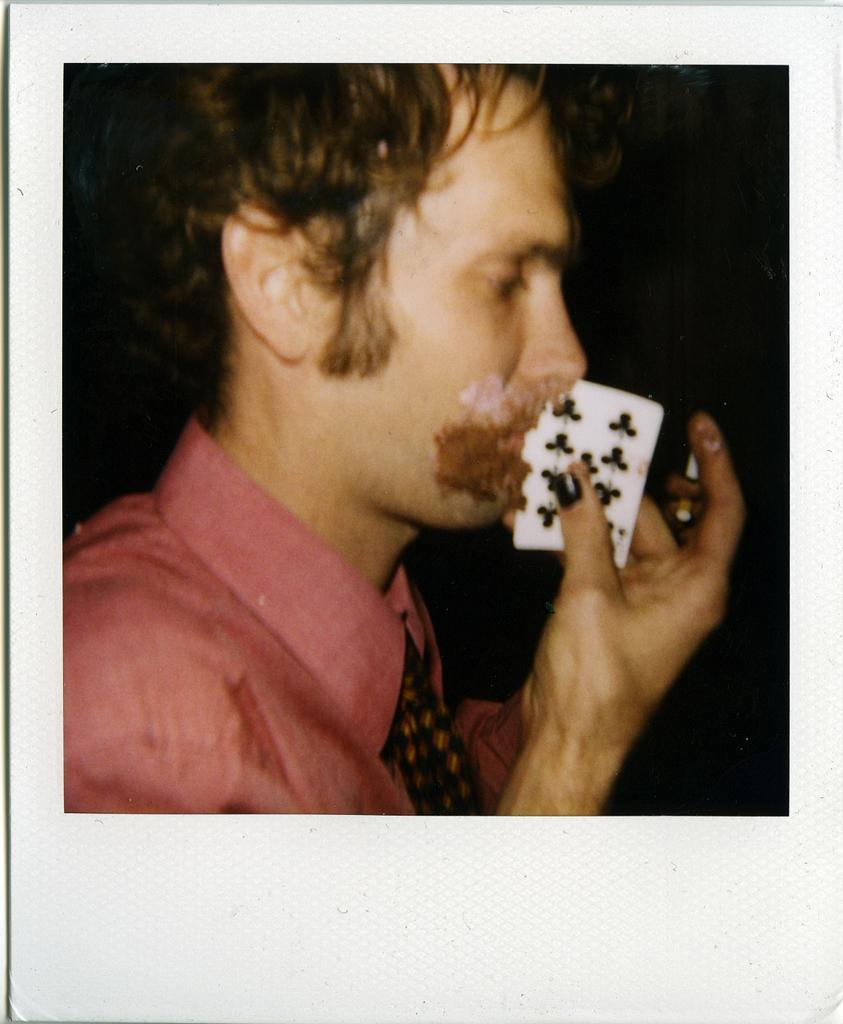Describe this image in one or two sentences. In this image, we can see photo of a picture contains person wearing clothes and holding a card with his hand. 